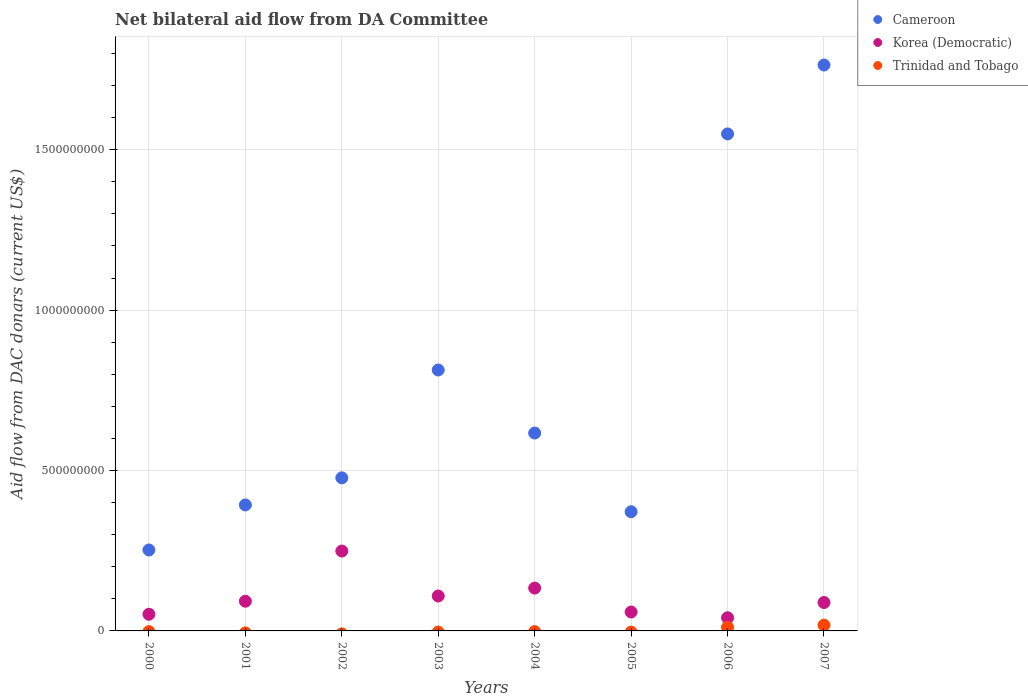How many different coloured dotlines are there?
Ensure brevity in your answer.  3. What is the aid flow in in Trinidad and Tobago in 2002?
Provide a short and direct response. 0. Across all years, what is the maximum aid flow in in Trinidad and Tobago?
Your answer should be compact. 1.80e+07. Across all years, what is the minimum aid flow in in Cameroon?
Keep it short and to the point. 2.52e+08. What is the total aid flow in in Trinidad and Tobago in the graph?
Keep it short and to the point. 2.94e+07. What is the difference between the aid flow in in Cameroon in 2000 and that in 2006?
Provide a short and direct response. -1.30e+09. What is the difference between the aid flow in in Korea (Democratic) in 2005 and the aid flow in in Trinidad and Tobago in 2001?
Offer a very short reply. 5.90e+07. What is the average aid flow in in Cameroon per year?
Your answer should be compact. 7.80e+08. In the year 2000, what is the difference between the aid flow in in Cameroon and aid flow in in Korea (Democratic)?
Provide a short and direct response. 2.00e+08. What is the ratio of the aid flow in in Cameroon in 2001 to that in 2002?
Provide a succinct answer. 0.82. Is the aid flow in in Cameroon in 2003 less than that in 2004?
Offer a terse response. No. What is the difference between the highest and the second highest aid flow in in Cameroon?
Your answer should be compact. 2.15e+08. What is the difference between the highest and the lowest aid flow in in Trinidad and Tobago?
Provide a succinct answer. 1.80e+07. In how many years, is the aid flow in in Cameroon greater than the average aid flow in in Cameroon taken over all years?
Provide a short and direct response. 3. Is the sum of the aid flow in in Korea (Democratic) in 2001 and 2005 greater than the maximum aid flow in in Cameroon across all years?
Make the answer very short. No. Does the aid flow in in Cameroon monotonically increase over the years?
Keep it short and to the point. No. How many years are there in the graph?
Provide a succinct answer. 8. What is the difference between two consecutive major ticks on the Y-axis?
Give a very brief answer. 5.00e+08. Where does the legend appear in the graph?
Ensure brevity in your answer.  Top right. What is the title of the graph?
Offer a terse response. Net bilateral aid flow from DA Committee. Does "Channel Islands" appear as one of the legend labels in the graph?
Your answer should be very brief. No. What is the label or title of the X-axis?
Make the answer very short. Years. What is the label or title of the Y-axis?
Provide a short and direct response. Aid flow from DAC donars (current US$). What is the Aid flow from DAC donars (current US$) in Cameroon in 2000?
Keep it short and to the point. 2.52e+08. What is the Aid flow from DAC donars (current US$) in Korea (Democratic) in 2000?
Ensure brevity in your answer.  5.19e+07. What is the Aid flow from DAC donars (current US$) of Trinidad and Tobago in 2000?
Keep it short and to the point. 0. What is the Aid flow from DAC donars (current US$) in Cameroon in 2001?
Keep it short and to the point. 3.93e+08. What is the Aid flow from DAC donars (current US$) in Korea (Democratic) in 2001?
Make the answer very short. 9.26e+07. What is the Aid flow from DAC donars (current US$) of Trinidad and Tobago in 2001?
Offer a terse response. 0. What is the Aid flow from DAC donars (current US$) in Cameroon in 2002?
Offer a very short reply. 4.77e+08. What is the Aid flow from DAC donars (current US$) of Korea (Democratic) in 2002?
Provide a succinct answer. 2.49e+08. What is the Aid flow from DAC donars (current US$) in Trinidad and Tobago in 2002?
Your answer should be very brief. 0. What is the Aid flow from DAC donars (current US$) in Cameroon in 2003?
Offer a terse response. 8.13e+08. What is the Aid flow from DAC donars (current US$) of Korea (Democratic) in 2003?
Give a very brief answer. 1.09e+08. What is the Aid flow from DAC donars (current US$) in Cameroon in 2004?
Ensure brevity in your answer.  6.17e+08. What is the Aid flow from DAC donars (current US$) in Korea (Democratic) in 2004?
Your response must be concise. 1.34e+08. What is the Aid flow from DAC donars (current US$) of Trinidad and Tobago in 2004?
Make the answer very short. 0. What is the Aid flow from DAC donars (current US$) in Cameroon in 2005?
Keep it short and to the point. 3.72e+08. What is the Aid flow from DAC donars (current US$) in Korea (Democratic) in 2005?
Ensure brevity in your answer.  5.90e+07. What is the Aid flow from DAC donars (current US$) in Trinidad and Tobago in 2005?
Offer a terse response. 0. What is the Aid flow from DAC donars (current US$) in Cameroon in 2006?
Your answer should be compact. 1.55e+09. What is the Aid flow from DAC donars (current US$) of Korea (Democratic) in 2006?
Provide a succinct answer. 4.10e+07. What is the Aid flow from DAC donars (current US$) in Trinidad and Tobago in 2006?
Make the answer very short. 1.14e+07. What is the Aid flow from DAC donars (current US$) of Cameroon in 2007?
Your response must be concise. 1.76e+09. What is the Aid flow from DAC donars (current US$) in Korea (Democratic) in 2007?
Your answer should be compact. 8.86e+07. What is the Aid flow from DAC donars (current US$) of Trinidad and Tobago in 2007?
Keep it short and to the point. 1.80e+07. Across all years, what is the maximum Aid flow from DAC donars (current US$) in Cameroon?
Your response must be concise. 1.76e+09. Across all years, what is the maximum Aid flow from DAC donars (current US$) of Korea (Democratic)?
Keep it short and to the point. 2.49e+08. Across all years, what is the maximum Aid flow from DAC donars (current US$) of Trinidad and Tobago?
Your response must be concise. 1.80e+07. Across all years, what is the minimum Aid flow from DAC donars (current US$) in Cameroon?
Provide a short and direct response. 2.52e+08. Across all years, what is the minimum Aid flow from DAC donars (current US$) in Korea (Democratic)?
Your answer should be very brief. 4.10e+07. Across all years, what is the minimum Aid flow from DAC donars (current US$) of Trinidad and Tobago?
Your answer should be very brief. 0. What is the total Aid flow from DAC donars (current US$) of Cameroon in the graph?
Your answer should be compact. 6.24e+09. What is the total Aid flow from DAC donars (current US$) of Korea (Democratic) in the graph?
Your answer should be compact. 8.25e+08. What is the total Aid flow from DAC donars (current US$) of Trinidad and Tobago in the graph?
Keep it short and to the point. 2.94e+07. What is the difference between the Aid flow from DAC donars (current US$) in Cameroon in 2000 and that in 2001?
Your response must be concise. -1.40e+08. What is the difference between the Aid flow from DAC donars (current US$) of Korea (Democratic) in 2000 and that in 2001?
Keep it short and to the point. -4.07e+07. What is the difference between the Aid flow from DAC donars (current US$) in Cameroon in 2000 and that in 2002?
Provide a succinct answer. -2.25e+08. What is the difference between the Aid flow from DAC donars (current US$) of Korea (Democratic) in 2000 and that in 2002?
Your response must be concise. -1.97e+08. What is the difference between the Aid flow from DAC donars (current US$) in Cameroon in 2000 and that in 2003?
Give a very brief answer. -5.61e+08. What is the difference between the Aid flow from DAC donars (current US$) of Korea (Democratic) in 2000 and that in 2003?
Your answer should be very brief. -5.69e+07. What is the difference between the Aid flow from DAC donars (current US$) in Cameroon in 2000 and that in 2004?
Offer a terse response. -3.65e+08. What is the difference between the Aid flow from DAC donars (current US$) of Korea (Democratic) in 2000 and that in 2004?
Provide a succinct answer. -8.16e+07. What is the difference between the Aid flow from DAC donars (current US$) in Cameroon in 2000 and that in 2005?
Your response must be concise. -1.19e+08. What is the difference between the Aid flow from DAC donars (current US$) of Korea (Democratic) in 2000 and that in 2005?
Make the answer very short. -7.04e+06. What is the difference between the Aid flow from DAC donars (current US$) of Cameroon in 2000 and that in 2006?
Make the answer very short. -1.30e+09. What is the difference between the Aid flow from DAC donars (current US$) in Korea (Democratic) in 2000 and that in 2006?
Provide a succinct answer. 1.09e+07. What is the difference between the Aid flow from DAC donars (current US$) of Cameroon in 2000 and that in 2007?
Your response must be concise. -1.51e+09. What is the difference between the Aid flow from DAC donars (current US$) in Korea (Democratic) in 2000 and that in 2007?
Your answer should be very brief. -3.66e+07. What is the difference between the Aid flow from DAC donars (current US$) of Cameroon in 2001 and that in 2002?
Provide a short and direct response. -8.45e+07. What is the difference between the Aid flow from DAC donars (current US$) of Korea (Democratic) in 2001 and that in 2002?
Provide a succinct answer. -1.56e+08. What is the difference between the Aid flow from DAC donars (current US$) in Cameroon in 2001 and that in 2003?
Offer a terse response. -4.21e+08. What is the difference between the Aid flow from DAC donars (current US$) in Korea (Democratic) in 2001 and that in 2003?
Your response must be concise. -1.62e+07. What is the difference between the Aid flow from DAC donars (current US$) of Cameroon in 2001 and that in 2004?
Your response must be concise. -2.24e+08. What is the difference between the Aid flow from DAC donars (current US$) in Korea (Democratic) in 2001 and that in 2004?
Offer a very short reply. -4.10e+07. What is the difference between the Aid flow from DAC donars (current US$) in Cameroon in 2001 and that in 2005?
Offer a very short reply. 2.12e+07. What is the difference between the Aid flow from DAC donars (current US$) of Korea (Democratic) in 2001 and that in 2005?
Give a very brief answer. 3.36e+07. What is the difference between the Aid flow from DAC donars (current US$) in Cameroon in 2001 and that in 2006?
Your response must be concise. -1.16e+09. What is the difference between the Aid flow from DAC donars (current US$) of Korea (Democratic) in 2001 and that in 2006?
Offer a very short reply. 5.16e+07. What is the difference between the Aid flow from DAC donars (current US$) of Cameroon in 2001 and that in 2007?
Ensure brevity in your answer.  -1.37e+09. What is the difference between the Aid flow from DAC donars (current US$) in Korea (Democratic) in 2001 and that in 2007?
Provide a short and direct response. 4.04e+06. What is the difference between the Aid flow from DAC donars (current US$) of Cameroon in 2002 and that in 2003?
Offer a very short reply. -3.36e+08. What is the difference between the Aid flow from DAC donars (current US$) in Korea (Democratic) in 2002 and that in 2003?
Provide a succinct answer. 1.40e+08. What is the difference between the Aid flow from DAC donars (current US$) of Cameroon in 2002 and that in 2004?
Provide a succinct answer. -1.40e+08. What is the difference between the Aid flow from DAC donars (current US$) of Korea (Democratic) in 2002 and that in 2004?
Offer a terse response. 1.15e+08. What is the difference between the Aid flow from DAC donars (current US$) in Cameroon in 2002 and that in 2005?
Keep it short and to the point. 1.06e+08. What is the difference between the Aid flow from DAC donars (current US$) in Korea (Democratic) in 2002 and that in 2005?
Offer a terse response. 1.90e+08. What is the difference between the Aid flow from DAC donars (current US$) of Cameroon in 2002 and that in 2006?
Keep it short and to the point. -1.07e+09. What is the difference between the Aid flow from DAC donars (current US$) in Korea (Democratic) in 2002 and that in 2006?
Give a very brief answer. 2.08e+08. What is the difference between the Aid flow from DAC donars (current US$) in Cameroon in 2002 and that in 2007?
Keep it short and to the point. -1.29e+09. What is the difference between the Aid flow from DAC donars (current US$) of Korea (Democratic) in 2002 and that in 2007?
Your answer should be very brief. 1.60e+08. What is the difference between the Aid flow from DAC donars (current US$) of Cameroon in 2003 and that in 2004?
Your answer should be compact. 1.97e+08. What is the difference between the Aid flow from DAC donars (current US$) of Korea (Democratic) in 2003 and that in 2004?
Give a very brief answer. -2.47e+07. What is the difference between the Aid flow from DAC donars (current US$) in Cameroon in 2003 and that in 2005?
Give a very brief answer. 4.42e+08. What is the difference between the Aid flow from DAC donars (current US$) of Korea (Democratic) in 2003 and that in 2005?
Offer a terse response. 4.99e+07. What is the difference between the Aid flow from DAC donars (current US$) in Cameroon in 2003 and that in 2006?
Offer a very short reply. -7.36e+08. What is the difference between the Aid flow from DAC donars (current US$) of Korea (Democratic) in 2003 and that in 2006?
Provide a short and direct response. 6.78e+07. What is the difference between the Aid flow from DAC donars (current US$) of Cameroon in 2003 and that in 2007?
Make the answer very short. -9.51e+08. What is the difference between the Aid flow from DAC donars (current US$) in Korea (Democratic) in 2003 and that in 2007?
Ensure brevity in your answer.  2.03e+07. What is the difference between the Aid flow from DAC donars (current US$) in Cameroon in 2004 and that in 2005?
Your answer should be very brief. 2.45e+08. What is the difference between the Aid flow from DAC donars (current US$) of Korea (Democratic) in 2004 and that in 2005?
Provide a succinct answer. 7.46e+07. What is the difference between the Aid flow from DAC donars (current US$) of Cameroon in 2004 and that in 2006?
Give a very brief answer. -9.32e+08. What is the difference between the Aid flow from DAC donars (current US$) in Korea (Democratic) in 2004 and that in 2006?
Keep it short and to the point. 9.25e+07. What is the difference between the Aid flow from DAC donars (current US$) of Cameroon in 2004 and that in 2007?
Give a very brief answer. -1.15e+09. What is the difference between the Aid flow from DAC donars (current US$) in Korea (Democratic) in 2004 and that in 2007?
Provide a succinct answer. 4.50e+07. What is the difference between the Aid flow from DAC donars (current US$) in Cameroon in 2005 and that in 2006?
Offer a terse response. -1.18e+09. What is the difference between the Aid flow from DAC donars (current US$) of Korea (Democratic) in 2005 and that in 2006?
Make the answer very short. 1.79e+07. What is the difference between the Aid flow from DAC donars (current US$) in Cameroon in 2005 and that in 2007?
Provide a short and direct response. -1.39e+09. What is the difference between the Aid flow from DAC donars (current US$) of Korea (Democratic) in 2005 and that in 2007?
Provide a short and direct response. -2.96e+07. What is the difference between the Aid flow from DAC donars (current US$) of Cameroon in 2006 and that in 2007?
Ensure brevity in your answer.  -2.15e+08. What is the difference between the Aid flow from DAC donars (current US$) in Korea (Democratic) in 2006 and that in 2007?
Offer a very short reply. -4.75e+07. What is the difference between the Aid flow from DAC donars (current US$) of Trinidad and Tobago in 2006 and that in 2007?
Offer a very short reply. -6.55e+06. What is the difference between the Aid flow from DAC donars (current US$) in Cameroon in 2000 and the Aid flow from DAC donars (current US$) in Korea (Democratic) in 2001?
Your answer should be very brief. 1.60e+08. What is the difference between the Aid flow from DAC donars (current US$) of Cameroon in 2000 and the Aid flow from DAC donars (current US$) of Korea (Democratic) in 2002?
Keep it short and to the point. 3.30e+06. What is the difference between the Aid flow from DAC donars (current US$) of Cameroon in 2000 and the Aid flow from DAC donars (current US$) of Korea (Democratic) in 2003?
Provide a succinct answer. 1.43e+08. What is the difference between the Aid flow from DAC donars (current US$) of Cameroon in 2000 and the Aid flow from DAC donars (current US$) of Korea (Democratic) in 2004?
Your answer should be compact. 1.19e+08. What is the difference between the Aid flow from DAC donars (current US$) of Cameroon in 2000 and the Aid flow from DAC donars (current US$) of Korea (Democratic) in 2005?
Offer a terse response. 1.93e+08. What is the difference between the Aid flow from DAC donars (current US$) of Cameroon in 2000 and the Aid flow from DAC donars (current US$) of Korea (Democratic) in 2006?
Give a very brief answer. 2.11e+08. What is the difference between the Aid flow from DAC donars (current US$) in Cameroon in 2000 and the Aid flow from DAC donars (current US$) in Trinidad and Tobago in 2006?
Your answer should be compact. 2.41e+08. What is the difference between the Aid flow from DAC donars (current US$) of Korea (Democratic) in 2000 and the Aid flow from DAC donars (current US$) of Trinidad and Tobago in 2006?
Your answer should be very brief. 4.05e+07. What is the difference between the Aid flow from DAC donars (current US$) in Cameroon in 2000 and the Aid flow from DAC donars (current US$) in Korea (Democratic) in 2007?
Provide a short and direct response. 1.64e+08. What is the difference between the Aid flow from DAC donars (current US$) of Cameroon in 2000 and the Aid flow from DAC donars (current US$) of Trinidad and Tobago in 2007?
Offer a very short reply. 2.34e+08. What is the difference between the Aid flow from DAC donars (current US$) of Korea (Democratic) in 2000 and the Aid flow from DAC donars (current US$) of Trinidad and Tobago in 2007?
Your answer should be compact. 3.40e+07. What is the difference between the Aid flow from DAC donars (current US$) in Cameroon in 2001 and the Aid flow from DAC donars (current US$) in Korea (Democratic) in 2002?
Your answer should be very brief. 1.44e+08. What is the difference between the Aid flow from DAC donars (current US$) of Cameroon in 2001 and the Aid flow from DAC donars (current US$) of Korea (Democratic) in 2003?
Keep it short and to the point. 2.84e+08. What is the difference between the Aid flow from DAC donars (current US$) of Cameroon in 2001 and the Aid flow from DAC donars (current US$) of Korea (Democratic) in 2004?
Provide a short and direct response. 2.59e+08. What is the difference between the Aid flow from DAC donars (current US$) of Cameroon in 2001 and the Aid flow from DAC donars (current US$) of Korea (Democratic) in 2005?
Provide a short and direct response. 3.34e+08. What is the difference between the Aid flow from DAC donars (current US$) of Cameroon in 2001 and the Aid flow from DAC donars (current US$) of Korea (Democratic) in 2006?
Give a very brief answer. 3.52e+08. What is the difference between the Aid flow from DAC donars (current US$) of Cameroon in 2001 and the Aid flow from DAC donars (current US$) of Trinidad and Tobago in 2006?
Your answer should be very brief. 3.81e+08. What is the difference between the Aid flow from DAC donars (current US$) of Korea (Democratic) in 2001 and the Aid flow from DAC donars (current US$) of Trinidad and Tobago in 2006?
Make the answer very short. 8.12e+07. What is the difference between the Aid flow from DAC donars (current US$) of Cameroon in 2001 and the Aid flow from DAC donars (current US$) of Korea (Democratic) in 2007?
Your answer should be very brief. 3.04e+08. What is the difference between the Aid flow from DAC donars (current US$) in Cameroon in 2001 and the Aid flow from DAC donars (current US$) in Trinidad and Tobago in 2007?
Offer a very short reply. 3.75e+08. What is the difference between the Aid flow from DAC donars (current US$) in Korea (Democratic) in 2001 and the Aid flow from DAC donars (current US$) in Trinidad and Tobago in 2007?
Offer a very short reply. 7.46e+07. What is the difference between the Aid flow from DAC donars (current US$) in Cameroon in 2002 and the Aid flow from DAC donars (current US$) in Korea (Democratic) in 2003?
Ensure brevity in your answer.  3.68e+08. What is the difference between the Aid flow from DAC donars (current US$) of Cameroon in 2002 and the Aid flow from DAC donars (current US$) of Korea (Democratic) in 2004?
Give a very brief answer. 3.44e+08. What is the difference between the Aid flow from DAC donars (current US$) in Cameroon in 2002 and the Aid flow from DAC donars (current US$) in Korea (Democratic) in 2005?
Offer a very short reply. 4.18e+08. What is the difference between the Aid flow from DAC donars (current US$) of Cameroon in 2002 and the Aid flow from DAC donars (current US$) of Korea (Democratic) in 2006?
Offer a terse response. 4.36e+08. What is the difference between the Aid flow from DAC donars (current US$) in Cameroon in 2002 and the Aid flow from DAC donars (current US$) in Trinidad and Tobago in 2006?
Ensure brevity in your answer.  4.66e+08. What is the difference between the Aid flow from DAC donars (current US$) of Korea (Democratic) in 2002 and the Aid flow from DAC donars (current US$) of Trinidad and Tobago in 2006?
Your answer should be very brief. 2.38e+08. What is the difference between the Aid flow from DAC donars (current US$) in Cameroon in 2002 and the Aid flow from DAC donars (current US$) in Korea (Democratic) in 2007?
Offer a very short reply. 3.89e+08. What is the difference between the Aid flow from DAC donars (current US$) of Cameroon in 2002 and the Aid flow from DAC donars (current US$) of Trinidad and Tobago in 2007?
Provide a succinct answer. 4.59e+08. What is the difference between the Aid flow from DAC donars (current US$) in Korea (Democratic) in 2002 and the Aid flow from DAC donars (current US$) in Trinidad and Tobago in 2007?
Ensure brevity in your answer.  2.31e+08. What is the difference between the Aid flow from DAC donars (current US$) in Cameroon in 2003 and the Aid flow from DAC donars (current US$) in Korea (Democratic) in 2004?
Your answer should be compact. 6.80e+08. What is the difference between the Aid flow from DAC donars (current US$) in Cameroon in 2003 and the Aid flow from DAC donars (current US$) in Korea (Democratic) in 2005?
Keep it short and to the point. 7.54e+08. What is the difference between the Aid flow from DAC donars (current US$) of Cameroon in 2003 and the Aid flow from DAC donars (current US$) of Korea (Democratic) in 2006?
Your answer should be very brief. 7.72e+08. What is the difference between the Aid flow from DAC donars (current US$) in Cameroon in 2003 and the Aid flow from DAC donars (current US$) in Trinidad and Tobago in 2006?
Your answer should be very brief. 8.02e+08. What is the difference between the Aid flow from DAC donars (current US$) of Korea (Democratic) in 2003 and the Aid flow from DAC donars (current US$) of Trinidad and Tobago in 2006?
Keep it short and to the point. 9.74e+07. What is the difference between the Aid flow from DAC donars (current US$) of Cameroon in 2003 and the Aid flow from DAC donars (current US$) of Korea (Democratic) in 2007?
Ensure brevity in your answer.  7.25e+08. What is the difference between the Aid flow from DAC donars (current US$) in Cameroon in 2003 and the Aid flow from DAC donars (current US$) in Trinidad and Tobago in 2007?
Your response must be concise. 7.95e+08. What is the difference between the Aid flow from DAC donars (current US$) in Korea (Democratic) in 2003 and the Aid flow from DAC donars (current US$) in Trinidad and Tobago in 2007?
Ensure brevity in your answer.  9.09e+07. What is the difference between the Aid flow from DAC donars (current US$) of Cameroon in 2004 and the Aid flow from DAC donars (current US$) of Korea (Democratic) in 2005?
Provide a short and direct response. 5.58e+08. What is the difference between the Aid flow from DAC donars (current US$) of Cameroon in 2004 and the Aid flow from DAC donars (current US$) of Korea (Democratic) in 2006?
Your response must be concise. 5.76e+08. What is the difference between the Aid flow from DAC donars (current US$) in Cameroon in 2004 and the Aid flow from DAC donars (current US$) in Trinidad and Tobago in 2006?
Provide a succinct answer. 6.05e+08. What is the difference between the Aid flow from DAC donars (current US$) in Korea (Democratic) in 2004 and the Aid flow from DAC donars (current US$) in Trinidad and Tobago in 2006?
Your answer should be very brief. 1.22e+08. What is the difference between the Aid flow from DAC donars (current US$) in Cameroon in 2004 and the Aid flow from DAC donars (current US$) in Korea (Democratic) in 2007?
Offer a terse response. 5.28e+08. What is the difference between the Aid flow from DAC donars (current US$) in Cameroon in 2004 and the Aid flow from DAC donars (current US$) in Trinidad and Tobago in 2007?
Offer a terse response. 5.99e+08. What is the difference between the Aid flow from DAC donars (current US$) of Korea (Democratic) in 2004 and the Aid flow from DAC donars (current US$) of Trinidad and Tobago in 2007?
Offer a terse response. 1.16e+08. What is the difference between the Aid flow from DAC donars (current US$) in Cameroon in 2005 and the Aid flow from DAC donars (current US$) in Korea (Democratic) in 2006?
Offer a very short reply. 3.30e+08. What is the difference between the Aid flow from DAC donars (current US$) of Cameroon in 2005 and the Aid flow from DAC donars (current US$) of Trinidad and Tobago in 2006?
Offer a terse response. 3.60e+08. What is the difference between the Aid flow from DAC donars (current US$) of Korea (Democratic) in 2005 and the Aid flow from DAC donars (current US$) of Trinidad and Tobago in 2006?
Your response must be concise. 4.76e+07. What is the difference between the Aid flow from DAC donars (current US$) in Cameroon in 2005 and the Aid flow from DAC donars (current US$) in Korea (Democratic) in 2007?
Your answer should be very brief. 2.83e+08. What is the difference between the Aid flow from DAC donars (current US$) of Cameroon in 2005 and the Aid flow from DAC donars (current US$) of Trinidad and Tobago in 2007?
Offer a very short reply. 3.54e+08. What is the difference between the Aid flow from DAC donars (current US$) in Korea (Democratic) in 2005 and the Aid flow from DAC donars (current US$) in Trinidad and Tobago in 2007?
Your response must be concise. 4.10e+07. What is the difference between the Aid flow from DAC donars (current US$) in Cameroon in 2006 and the Aid flow from DAC donars (current US$) in Korea (Democratic) in 2007?
Make the answer very short. 1.46e+09. What is the difference between the Aid flow from DAC donars (current US$) of Cameroon in 2006 and the Aid flow from DAC donars (current US$) of Trinidad and Tobago in 2007?
Offer a very short reply. 1.53e+09. What is the difference between the Aid flow from DAC donars (current US$) of Korea (Democratic) in 2006 and the Aid flow from DAC donars (current US$) of Trinidad and Tobago in 2007?
Your answer should be compact. 2.31e+07. What is the average Aid flow from DAC donars (current US$) of Cameroon per year?
Your answer should be very brief. 7.80e+08. What is the average Aid flow from DAC donars (current US$) in Korea (Democratic) per year?
Ensure brevity in your answer.  1.03e+08. What is the average Aid flow from DAC donars (current US$) of Trinidad and Tobago per year?
Offer a terse response. 3.67e+06. In the year 2000, what is the difference between the Aid flow from DAC donars (current US$) of Cameroon and Aid flow from DAC donars (current US$) of Korea (Democratic)?
Your response must be concise. 2.00e+08. In the year 2001, what is the difference between the Aid flow from DAC donars (current US$) of Cameroon and Aid flow from DAC donars (current US$) of Korea (Democratic)?
Ensure brevity in your answer.  3.00e+08. In the year 2002, what is the difference between the Aid flow from DAC donars (current US$) of Cameroon and Aid flow from DAC donars (current US$) of Korea (Democratic)?
Give a very brief answer. 2.28e+08. In the year 2003, what is the difference between the Aid flow from DAC donars (current US$) of Cameroon and Aid flow from DAC donars (current US$) of Korea (Democratic)?
Make the answer very short. 7.05e+08. In the year 2004, what is the difference between the Aid flow from DAC donars (current US$) of Cameroon and Aid flow from DAC donars (current US$) of Korea (Democratic)?
Keep it short and to the point. 4.83e+08. In the year 2005, what is the difference between the Aid flow from DAC donars (current US$) in Cameroon and Aid flow from DAC donars (current US$) in Korea (Democratic)?
Your answer should be compact. 3.13e+08. In the year 2006, what is the difference between the Aid flow from DAC donars (current US$) in Cameroon and Aid flow from DAC donars (current US$) in Korea (Democratic)?
Provide a short and direct response. 1.51e+09. In the year 2006, what is the difference between the Aid flow from DAC donars (current US$) in Cameroon and Aid flow from DAC donars (current US$) in Trinidad and Tobago?
Your response must be concise. 1.54e+09. In the year 2006, what is the difference between the Aid flow from DAC donars (current US$) in Korea (Democratic) and Aid flow from DAC donars (current US$) in Trinidad and Tobago?
Provide a succinct answer. 2.96e+07. In the year 2007, what is the difference between the Aid flow from DAC donars (current US$) of Cameroon and Aid flow from DAC donars (current US$) of Korea (Democratic)?
Provide a short and direct response. 1.68e+09. In the year 2007, what is the difference between the Aid flow from DAC donars (current US$) in Cameroon and Aid flow from DAC donars (current US$) in Trinidad and Tobago?
Your response must be concise. 1.75e+09. In the year 2007, what is the difference between the Aid flow from DAC donars (current US$) of Korea (Democratic) and Aid flow from DAC donars (current US$) of Trinidad and Tobago?
Offer a terse response. 7.06e+07. What is the ratio of the Aid flow from DAC donars (current US$) of Cameroon in 2000 to that in 2001?
Make the answer very short. 0.64. What is the ratio of the Aid flow from DAC donars (current US$) of Korea (Democratic) in 2000 to that in 2001?
Your answer should be compact. 0.56. What is the ratio of the Aid flow from DAC donars (current US$) of Cameroon in 2000 to that in 2002?
Offer a very short reply. 0.53. What is the ratio of the Aid flow from DAC donars (current US$) of Korea (Democratic) in 2000 to that in 2002?
Your answer should be very brief. 0.21. What is the ratio of the Aid flow from DAC donars (current US$) of Cameroon in 2000 to that in 2003?
Ensure brevity in your answer.  0.31. What is the ratio of the Aid flow from DAC donars (current US$) in Korea (Democratic) in 2000 to that in 2003?
Provide a succinct answer. 0.48. What is the ratio of the Aid flow from DAC donars (current US$) of Cameroon in 2000 to that in 2004?
Offer a very short reply. 0.41. What is the ratio of the Aid flow from DAC donars (current US$) of Korea (Democratic) in 2000 to that in 2004?
Ensure brevity in your answer.  0.39. What is the ratio of the Aid flow from DAC donars (current US$) of Cameroon in 2000 to that in 2005?
Keep it short and to the point. 0.68. What is the ratio of the Aid flow from DAC donars (current US$) in Korea (Democratic) in 2000 to that in 2005?
Your answer should be compact. 0.88. What is the ratio of the Aid flow from DAC donars (current US$) of Cameroon in 2000 to that in 2006?
Your answer should be compact. 0.16. What is the ratio of the Aid flow from DAC donars (current US$) in Korea (Democratic) in 2000 to that in 2006?
Provide a short and direct response. 1.26. What is the ratio of the Aid flow from DAC donars (current US$) of Cameroon in 2000 to that in 2007?
Make the answer very short. 0.14. What is the ratio of the Aid flow from DAC donars (current US$) of Korea (Democratic) in 2000 to that in 2007?
Offer a terse response. 0.59. What is the ratio of the Aid flow from DAC donars (current US$) of Cameroon in 2001 to that in 2002?
Ensure brevity in your answer.  0.82. What is the ratio of the Aid flow from DAC donars (current US$) in Korea (Democratic) in 2001 to that in 2002?
Make the answer very short. 0.37. What is the ratio of the Aid flow from DAC donars (current US$) of Cameroon in 2001 to that in 2003?
Your answer should be compact. 0.48. What is the ratio of the Aid flow from DAC donars (current US$) of Korea (Democratic) in 2001 to that in 2003?
Your answer should be compact. 0.85. What is the ratio of the Aid flow from DAC donars (current US$) of Cameroon in 2001 to that in 2004?
Keep it short and to the point. 0.64. What is the ratio of the Aid flow from DAC donars (current US$) of Korea (Democratic) in 2001 to that in 2004?
Keep it short and to the point. 0.69. What is the ratio of the Aid flow from DAC donars (current US$) in Cameroon in 2001 to that in 2005?
Your answer should be compact. 1.06. What is the ratio of the Aid flow from DAC donars (current US$) of Korea (Democratic) in 2001 to that in 2005?
Your answer should be very brief. 1.57. What is the ratio of the Aid flow from DAC donars (current US$) of Cameroon in 2001 to that in 2006?
Provide a succinct answer. 0.25. What is the ratio of the Aid flow from DAC donars (current US$) in Korea (Democratic) in 2001 to that in 2006?
Provide a short and direct response. 2.26. What is the ratio of the Aid flow from DAC donars (current US$) in Cameroon in 2001 to that in 2007?
Keep it short and to the point. 0.22. What is the ratio of the Aid flow from DAC donars (current US$) of Korea (Democratic) in 2001 to that in 2007?
Your answer should be very brief. 1.05. What is the ratio of the Aid flow from DAC donars (current US$) of Cameroon in 2002 to that in 2003?
Give a very brief answer. 0.59. What is the ratio of the Aid flow from DAC donars (current US$) of Korea (Democratic) in 2002 to that in 2003?
Provide a succinct answer. 2.29. What is the ratio of the Aid flow from DAC donars (current US$) in Cameroon in 2002 to that in 2004?
Keep it short and to the point. 0.77. What is the ratio of the Aid flow from DAC donars (current US$) in Korea (Democratic) in 2002 to that in 2004?
Give a very brief answer. 1.86. What is the ratio of the Aid flow from DAC donars (current US$) in Cameroon in 2002 to that in 2005?
Ensure brevity in your answer.  1.28. What is the ratio of the Aid flow from DAC donars (current US$) of Korea (Democratic) in 2002 to that in 2005?
Provide a succinct answer. 4.22. What is the ratio of the Aid flow from DAC donars (current US$) in Cameroon in 2002 to that in 2006?
Give a very brief answer. 0.31. What is the ratio of the Aid flow from DAC donars (current US$) of Korea (Democratic) in 2002 to that in 2006?
Your answer should be very brief. 6.07. What is the ratio of the Aid flow from DAC donars (current US$) in Cameroon in 2002 to that in 2007?
Your answer should be very brief. 0.27. What is the ratio of the Aid flow from DAC donars (current US$) of Korea (Democratic) in 2002 to that in 2007?
Make the answer very short. 2.81. What is the ratio of the Aid flow from DAC donars (current US$) in Cameroon in 2003 to that in 2004?
Keep it short and to the point. 1.32. What is the ratio of the Aid flow from DAC donars (current US$) of Korea (Democratic) in 2003 to that in 2004?
Provide a short and direct response. 0.81. What is the ratio of the Aid flow from DAC donars (current US$) in Cameroon in 2003 to that in 2005?
Provide a succinct answer. 2.19. What is the ratio of the Aid flow from DAC donars (current US$) in Korea (Democratic) in 2003 to that in 2005?
Keep it short and to the point. 1.85. What is the ratio of the Aid flow from DAC donars (current US$) of Cameroon in 2003 to that in 2006?
Offer a very short reply. 0.53. What is the ratio of the Aid flow from DAC donars (current US$) of Korea (Democratic) in 2003 to that in 2006?
Make the answer very short. 2.65. What is the ratio of the Aid flow from DAC donars (current US$) of Cameroon in 2003 to that in 2007?
Your response must be concise. 0.46. What is the ratio of the Aid flow from DAC donars (current US$) in Korea (Democratic) in 2003 to that in 2007?
Your answer should be very brief. 1.23. What is the ratio of the Aid flow from DAC donars (current US$) in Cameroon in 2004 to that in 2005?
Offer a terse response. 1.66. What is the ratio of the Aid flow from DAC donars (current US$) of Korea (Democratic) in 2004 to that in 2005?
Your answer should be very brief. 2.27. What is the ratio of the Aid flow from DAC donars (current US$) of Cameroon in 2004 to that in 2006?
Provide a short and direct response. 0.4. What is the ratio of the Aid flow from DAC donars (current US$) of Korea (Democratic) in 2004 to that in 2006?
Give a very brief answer. 3.25. What is the ratio of the Aid flow from DAC donars (current US$) of Cameroon in 2004 to that in 2007?
Ensure brevity in your answer.  0.35. What is the ratio of the Aid flow from DAC donars (current US$) of Korea (Democratic) in 2004 to that in 2007?
Offer a very short reply. 1.51. What is the ratio of the Aid flow from DAC donars (current US$) of Cameroon in 2005 to that in 2006?
Make the answer very short. 0.24. What is the ratio of the Aid flow from DAC donars (current US$) of Korea (Democratic) in 2005 to that in 2006?
Keep it short and to the point. 1.44. What is the ratio of the Aid flow from DAC donars (current US$) in Cameroon in 2005 to that in 2007?
Make the answer very short. 0.21. What is the ratio of the Aid flow from DAC donars (current US$) in Korea (Democratic) in 2005 to that in 2007?
Your answer should be very brief. 0.67. What is the ratio of the Aid flow from DAC donars (current US$) of Cameroon in 2006 to that in 2007?
Offer a terse response. 0.88. What is the ratio of the Aid flow from DAC donars (current US$) of Korea (Democratic) in 2006 to that in 2007?
Ensure brevity in your answer.  0.46. What is the ratio of the Aid flow from DAC donars (current US$) in Trinidad and Tobago in 2006 to that in 2007?
Provide a short and direct response. 0.64. What is the difference between the highest and the second highest Aid flow from DAC donars (current US$) in Cameroon?
Make the answer very short. 2.15e+08. What is the difference between the highest and the second highest Aid flow from DAC donars (current US$) of Korea (Democratic)?
Provide a succinct answer. 1.15e+08. What is the difference between the highest and the lowest Aid flow from DAC donars (current US$) of Cameroon?
Ensure brevity in your answer.  1.51e+09. What is the difference between the highest and the lowest Aid flow from DAC donars (current US$) in Korea (Democratic)?
Your answer should be compact. 2.08e+08. What is the difference between the highest and the lowest Aid flow from DAC donars (current US$) of Trinidad and Tobago?
Your answer should be very brief. 1.80e+07. 